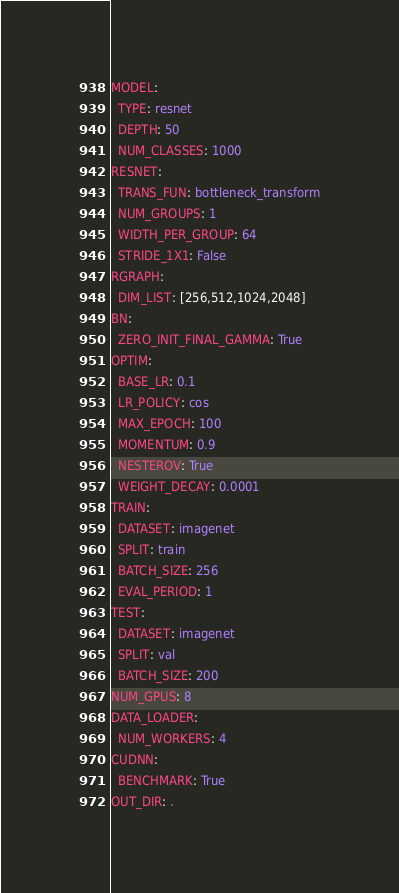Convert code to text. <code><loc_0><loc_0><loc_500><loc_500><_YAML_>MODEL:
  TYPE: resnet
  DEPTH: 50
  NUM_CLASSES: 1000
RESNET:
  TRANS_FUN: bottleneck_transform
  NUM_GROUPS: 1
  WIDTH_PER_GROUP: 64
  STRIDE_1X1: False
RGRAPH:
  DIM_LIST: [256,512,1024,2048]
BN:
  ZERO_INIT_FINAL_GAMMA: True
OPTIM:
  BASE_LR: 0.1
  LR_POLICY: cos
  MAX_EPOCH: 100
  MOMENTUM: 0.9
  NESTEROV: True
  WEIGHT_DECAY: 0.0001
TRAIN:
  DATASET: imagenet
  SPLIT: train
  BATCH_SIZE: 256
  EVAL_PERIOD: 1
TEST:
  DATASET: imagenet
  SPLIT: val
  BATCH_SIZE: 200
NUM_GPUS: 8
DATA_LOADER:
  NUM_WORKERS: 4
CUDNN:
  BENCHMARK: True
OUT_DIR: .
</code> 